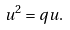Convert formula to latex. <formula><loc_0><loc_0><loc_500><loc_500>u ^ { 2 } = q u .</formula> 